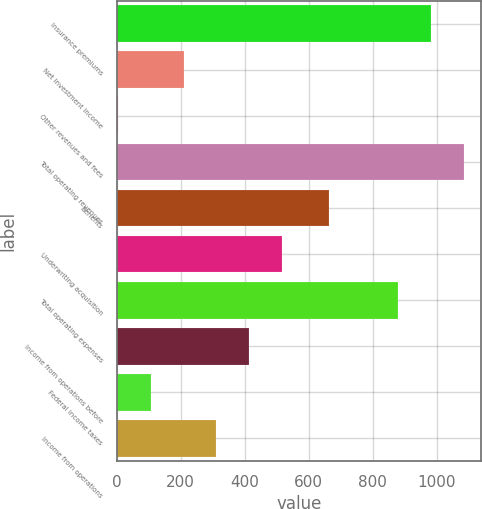Convert chart. <chart><loc_0><loc_0><loc_500><loc_500><bar_chart><fcel>Insurance premiums<fcel>Net investment income<fcel>Other revenues and fees<fcel>Total operating revenues<fcel>Benefits<fcel>Underwriting acquisition<fcel>Total operating expenses<fcel>Income from operations before<fcel>Federal income taxes<fcel>Income from operations<nl><fcel>982.9<fcel>208.8<fcel>3<fcel>1085.8<fcel>663<fcel>517.5<fcel>880<fcel>414.6<fcel>105.9<fcel>311.7<nl></chart> 